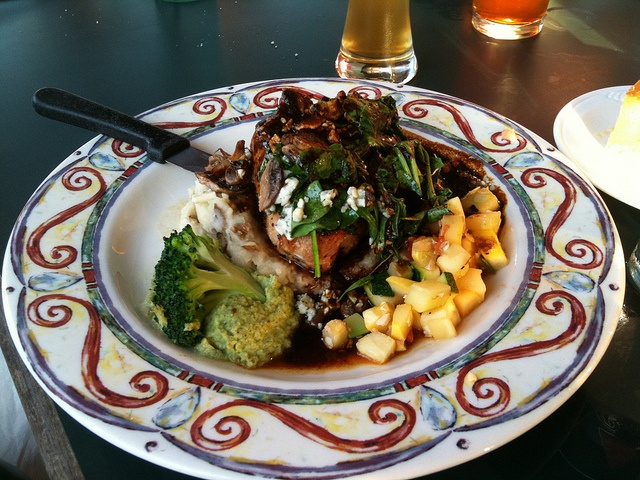Describe the objects in this image and their specific colors. I can see dining table in black, lightgray, maroon, and gray tones, broccoli in black and olive tones, cup in black, maroon, olive, and ivory tones, knife in black, blue, darkblue, and gray tones, and cup in black, brown, red, and ivory tones in this image. 